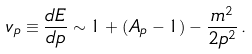<formula> <loc_0><loc_0><loc_500><loc_500>v _ { p } \equiv \frac { d E } { d p } \sim 1 + ( A _ { p } - 1 ) - \frac { m ^ { 2 } } { 2 p ^ { 2 } } \, .</formula> 